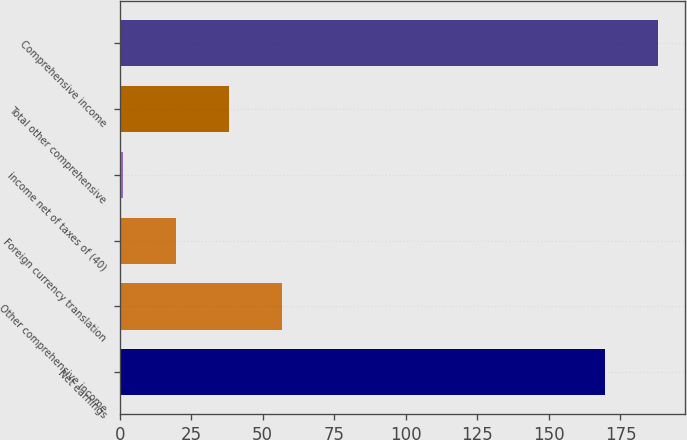Convert chart to OTSL. <chart><loc_0><loc_0><loc_500><loc_500><bar_chart><fcel>Net earnings<fcel>Other comprehensive income<fcel>Foreign currency translation<fcel>income net of taxes of (40)<fcel>Total other comprehensive<fcel>Comprehensive income<nl><fcel>169.6<fcel>56.9<fcel>19.7<fcel>1.1<fcel>38.3<fcel>188.2<nl></chart> 